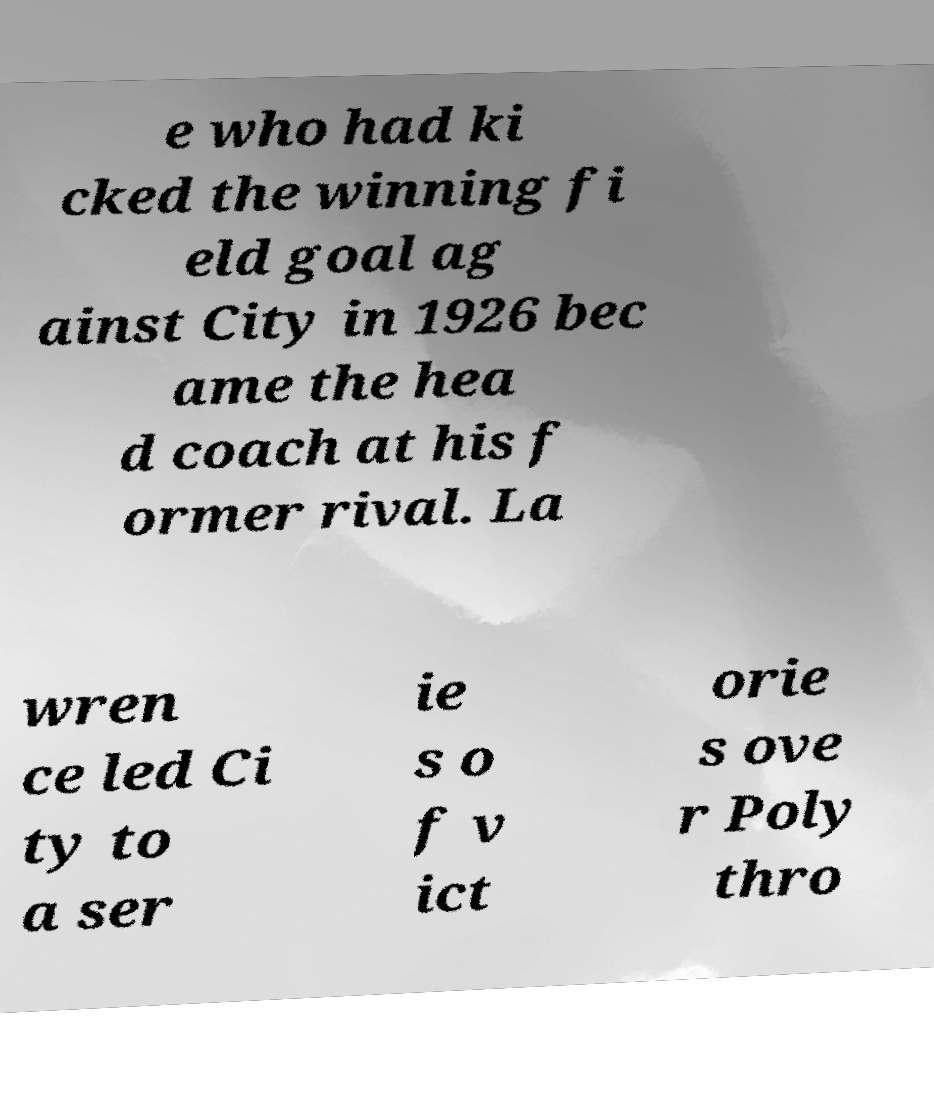What messages or text are displayed in this image? I need them in a readable, typed format. e who had ki cked the winning fi eld goal ag ainst City in 1926 bec ame the hea d coach at his f ormer rival. La wren ce led Ci ty to a ser ie s o f v ict orie s ove r Poly thro 